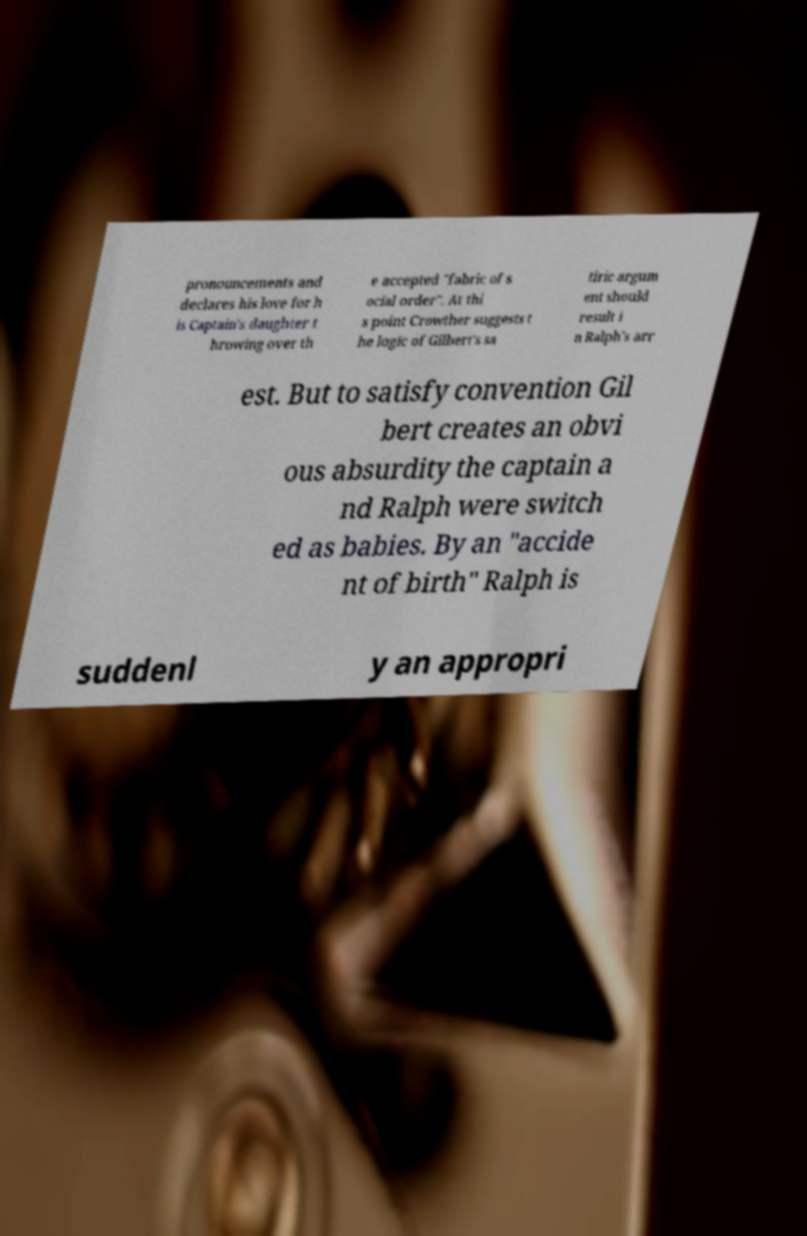Please identify and transcribe the text found in this image. pronouncements and declares his love for h is Captain's daughter t hrowing over th e accepted "fabric of s ocial order". At thi s point Crowther suggests t he logic of Gilbert's sa tiric argum ent should result i n Ralph's arr est. But to satisfy convention Gil bert creates an obvi ous absurdity the captain a nd Ralph were switch ed as babies. By an "accide nt of birth" Ralph is suddenl y an appropri 